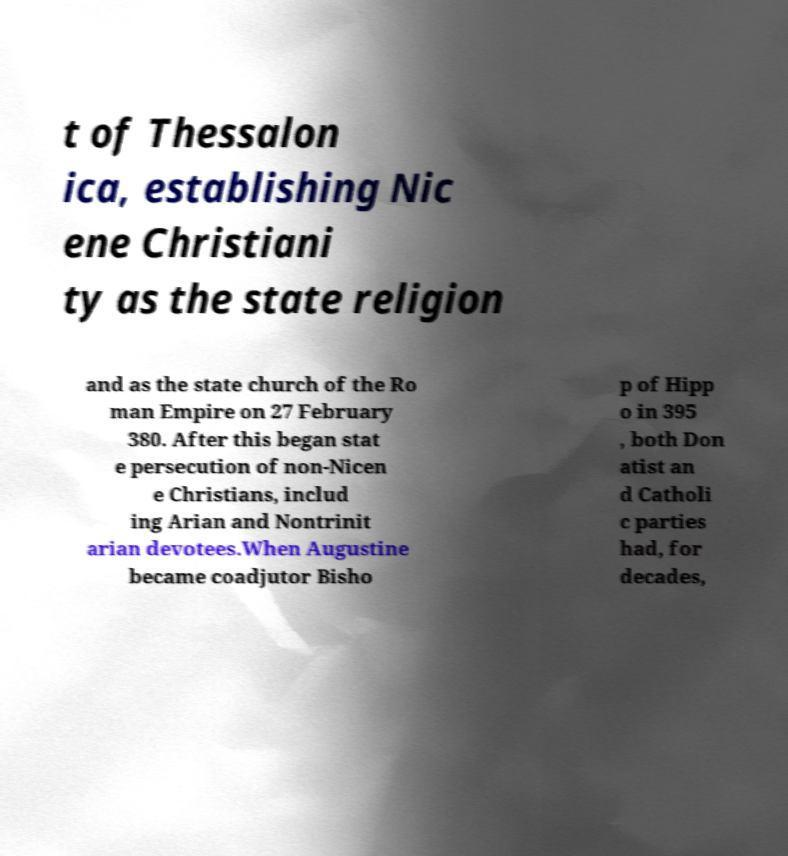I need the written content from this picture converted into text. Can you do that? t of Thessalon ica, establishing Nic ene Christiani ty as the state religion and as the state church of the Ro man Empire on 27 February 380. After this began stat e persecution of non-Nicen e Christians, includ ing Arian and Nontrinit arian devotees.When Augustine became coadjutor Bisho p of Hipp o in 395 , both Don atist an d Catholi c parties had, for decades, 